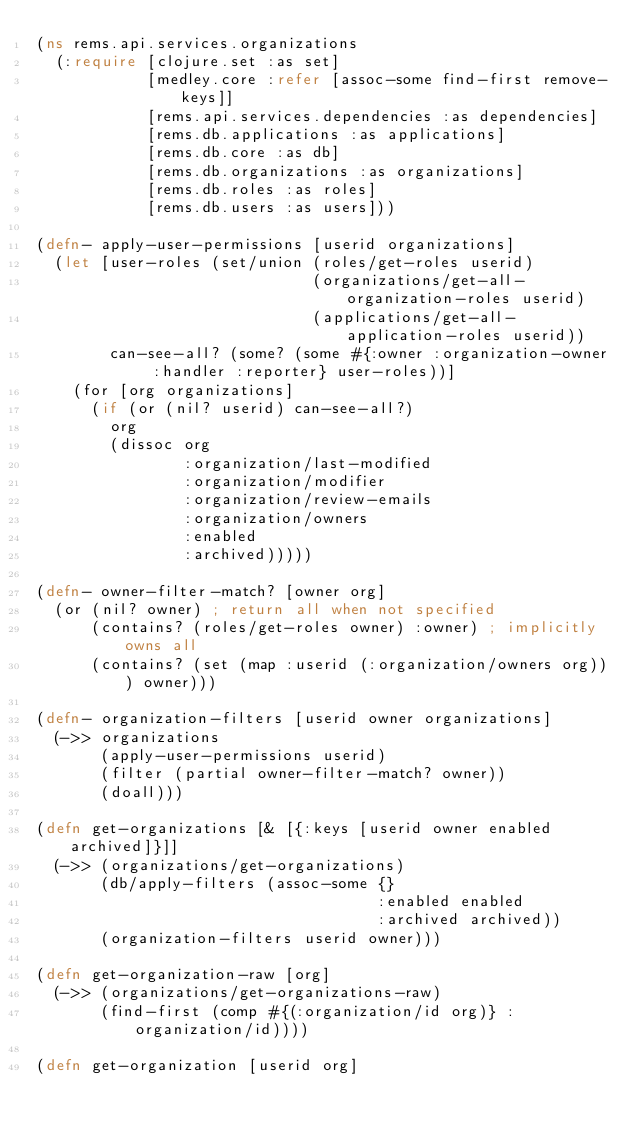<code> <loc_0><loc_0><loc_500><loc_500><_Clojure_>(ns rems.api.services.organizations
  (:require [clojure.set :as set]
            [medley.core :refer [assoc-some find-first remove-keys]]
            [rems.api.services.dependencies :as dependencies]
            [rems.db.applications :as applications]
            [rems.db.core :as db]
            [rems.db.organizations :as organizations]
            [rems.db.roles :as roles]
            [rems.db.users :as users]))

(defn- apply-user-permissions [userid organizations]
  (let [user-roles (set/union (roles/get-roles userid)
                              (organizations/get-all-organization-roles userid)
                              (applications/get-all-application-roles userid))
        can-see-all? (some? (some #{:owner :organization-owner :handler :reporter} user-roles))]
    (for [org organizations]
      (if (or (nil? userid) can-see-all?)
        org
        (dissoc org
                :organization/last-modified
                :organization/modifier
                :organization/review-emails
                :organization/owners
                :enabled
                :archived)))))

(defn- owner-filter-match? [owner org]
  (or (nil? owner) ; return all when not specified
      (contains? (roles/get-roles owner) :owner) ; implicitly owns all
      (contains? (set (map :userid (:organization/owners org))) owner)))

(defn- organization-filters [userid owner organizations]
  (->> organizations
       (apply-user-permissions userid)
       (filter (partial owner-filter-match? owner))
       (doall)))

(defn get-organizations [& [{:keys [userid owner enabled archived]}]]
  (->> (organizations/get-organizations)
       (db/apply-filters (assoc-some {}
                                     :enabled enabled
                                     :archived archived))
       (organization-filters userid owner)))

(defn get-organization-raw [org]
  (->> (organizations/get-organizations-raw)
       (find-first (comp #{(:organization/id org)} :organization/id))))

(defn get-organization [userid org]</code> 